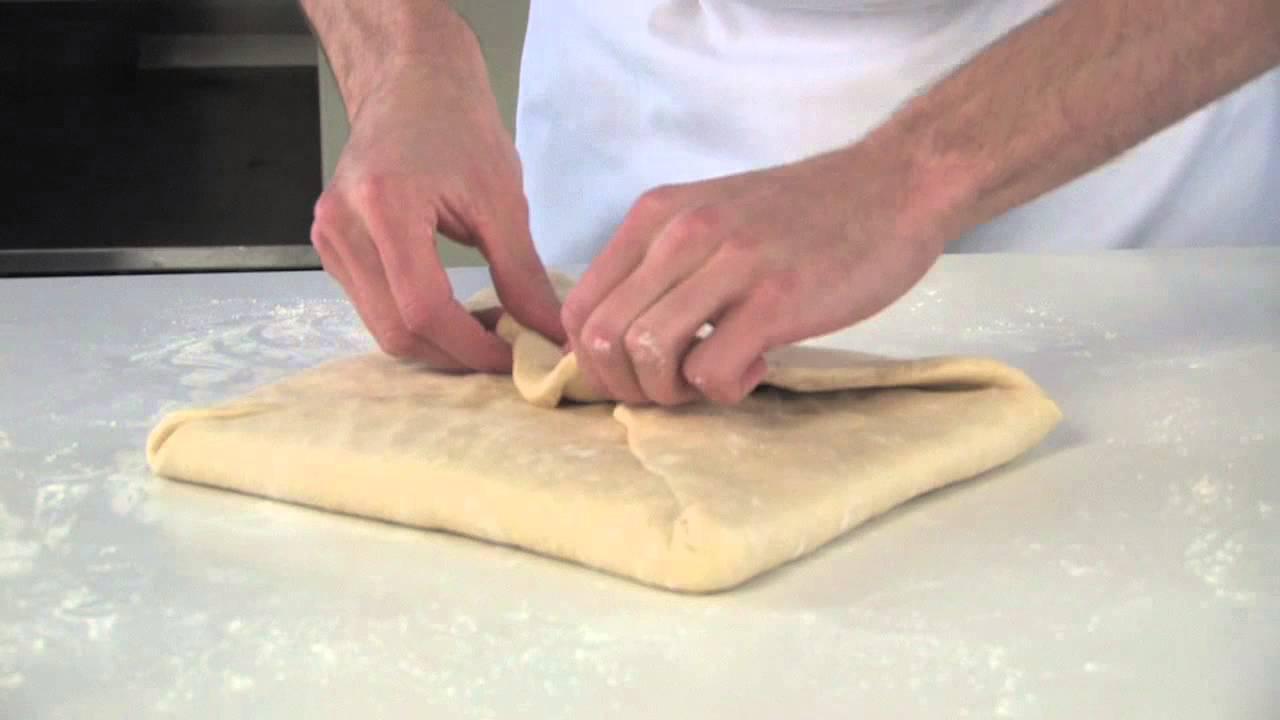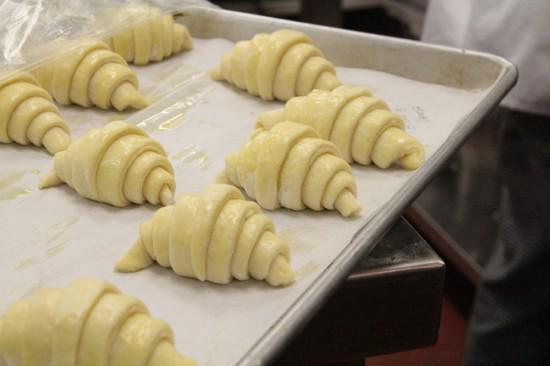The first image is the image on the left, the second image is the image on the right. Given the left and right images, does the statement "A single person is working with dough in the image on the left." hold true? Answer yes or no. Yes. 